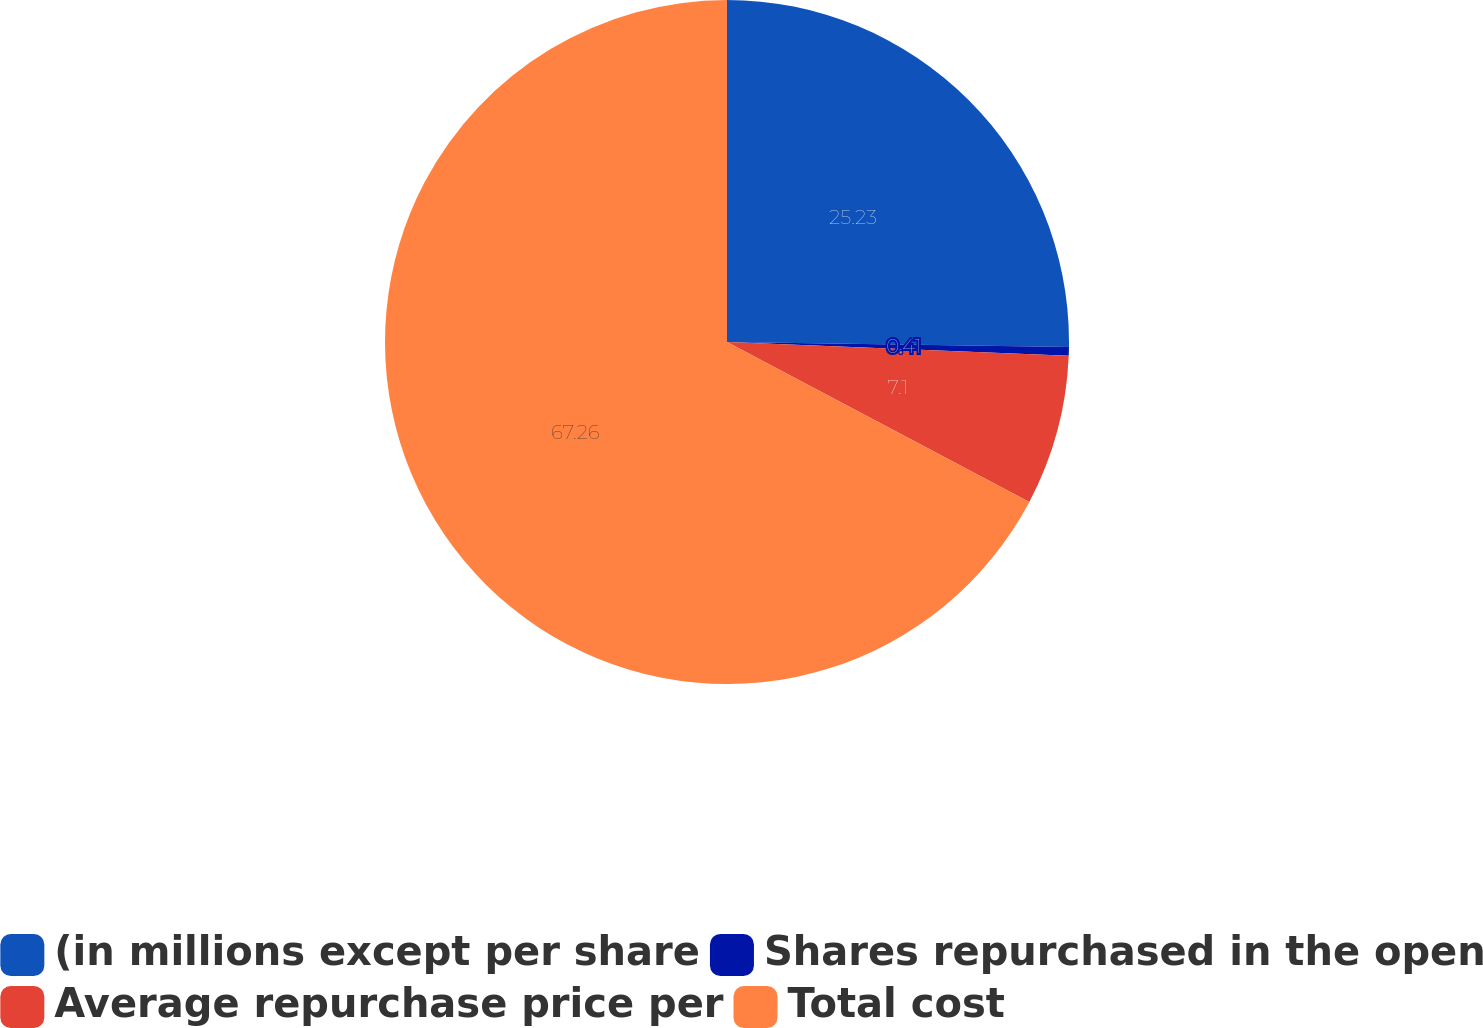Convert chart. <chart><loc_0><loc_0><loc_500><loc_500><pie_chart><fcel>(in millions except per share<fcel>Shares repurchased in the open<fcel>Average repurchase price per<fcel>Total cost<nl><fcel>25.23%<fcel>0.41%<fcel>7.1%<fcel>67.25%<nl></chart> 